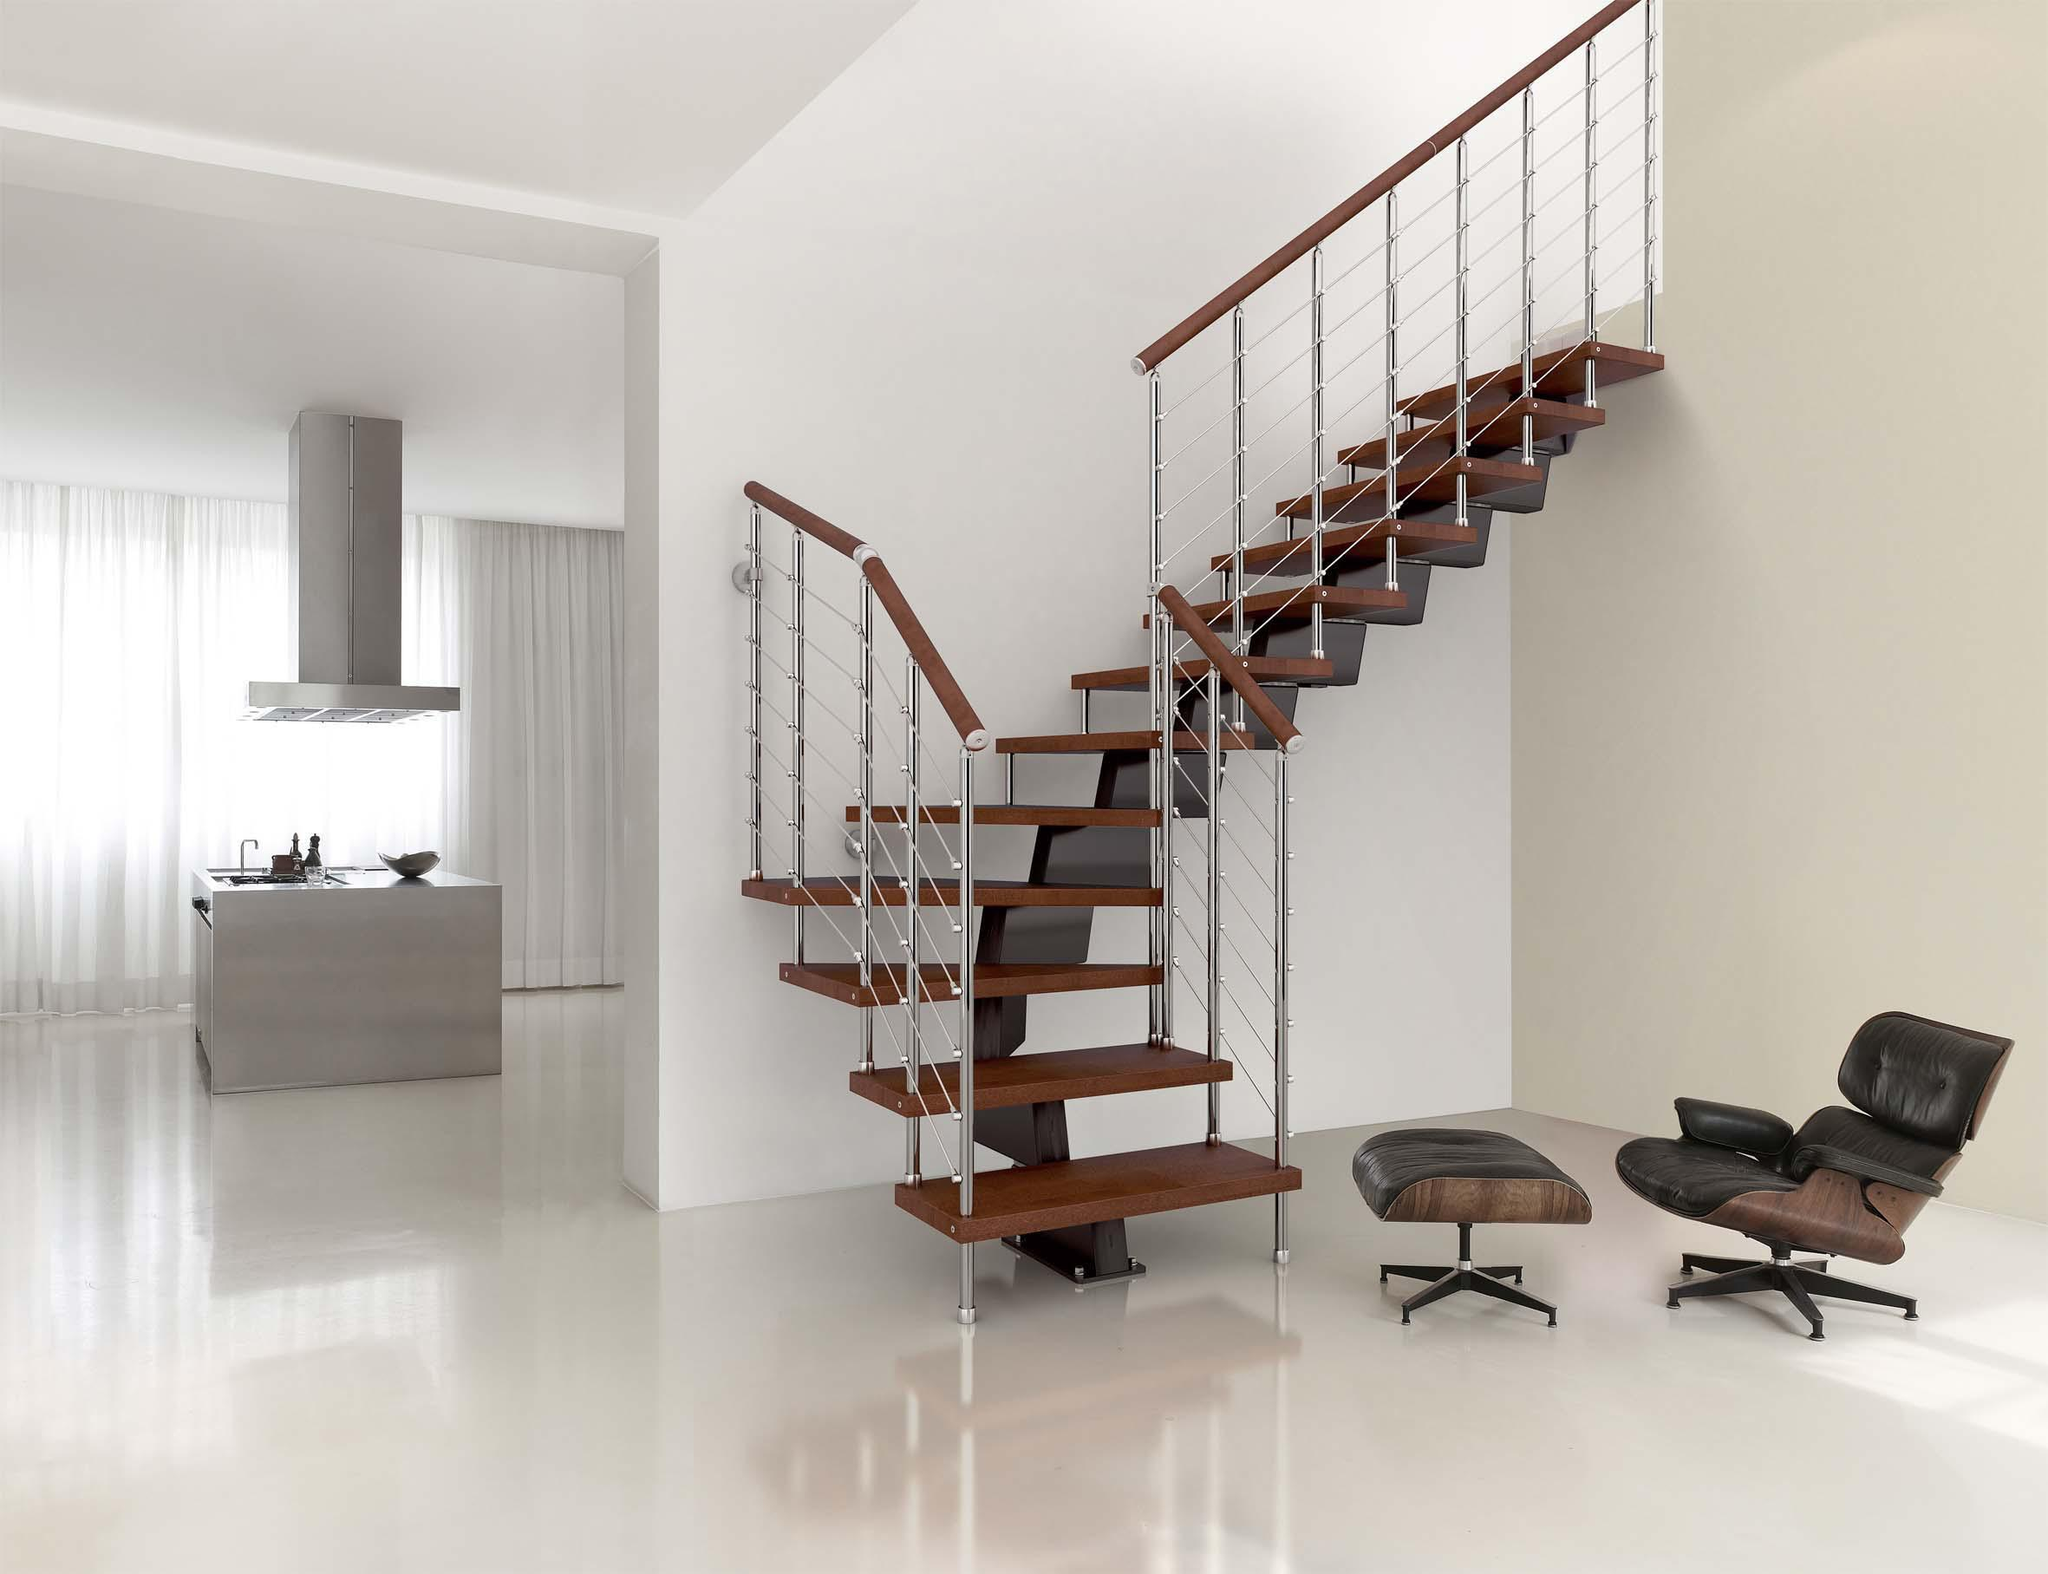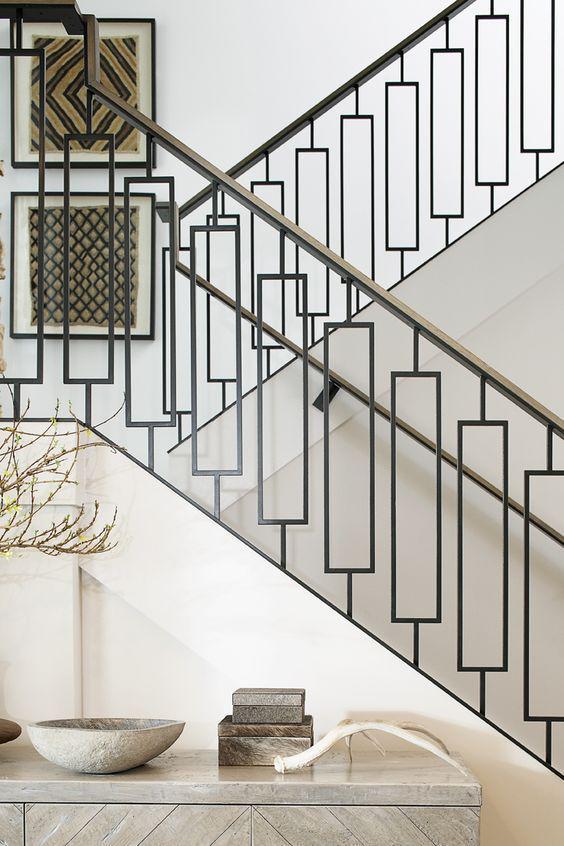The first image is the image on the left, the second image is the image on the right. For the images displayed, is the sentence "One set of stairs has partly silver colored railings." factually correct? Answer yes or no. Yes. The first image is the image on the left, the second image is the image on the right. Evaluate the accuracy of this statement regarding the images: "The staircases in both images have metal railings.". Is it true? Answer yes or no. Yes. 